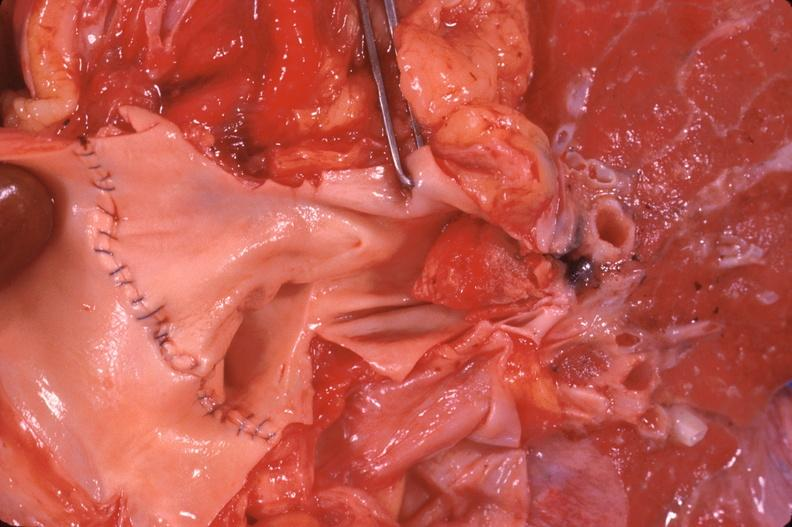what is present?
Answer the question using a single word or phrase. Respiratory 